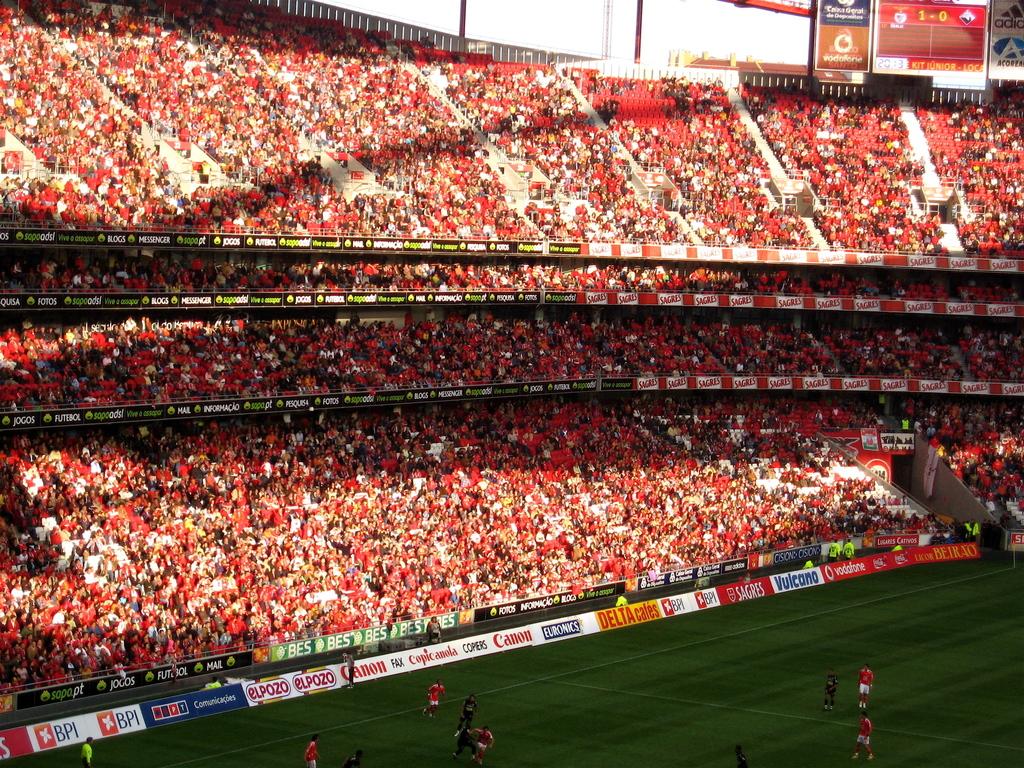What camera company is shown in red font?
Give a very brief answer. Canon. 